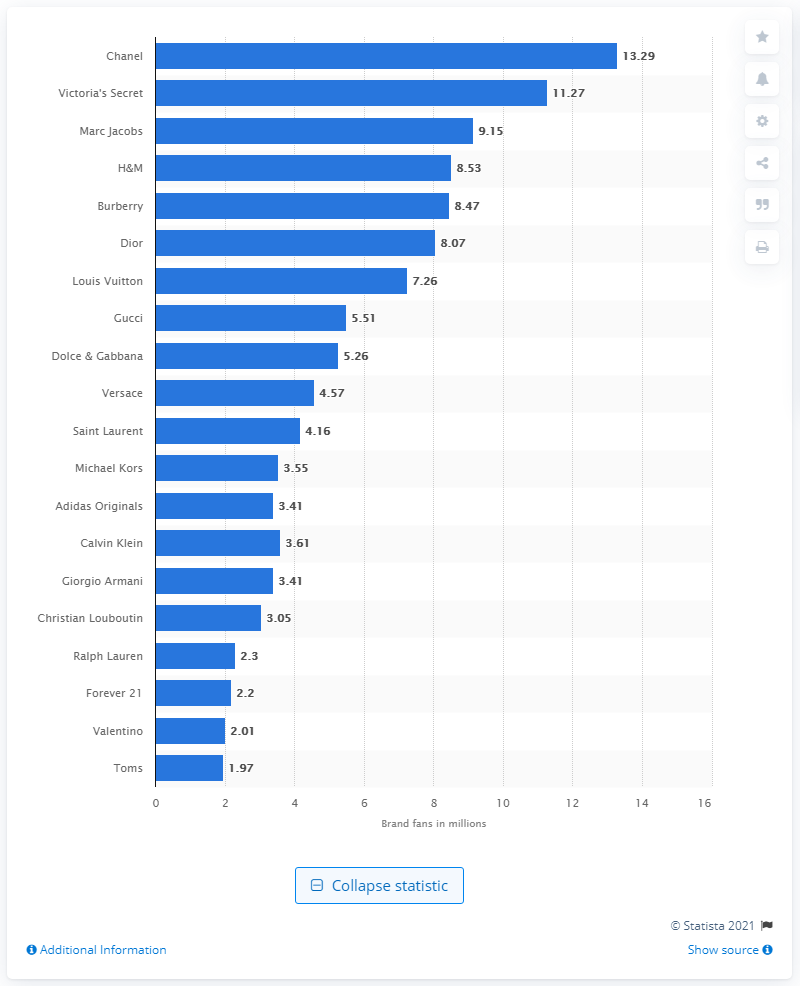Point out several critical features in this image. In July 2018, Victoria's Secret was ranked as the second most popular lingerie retailer on Twitter, according to a recent survey. 